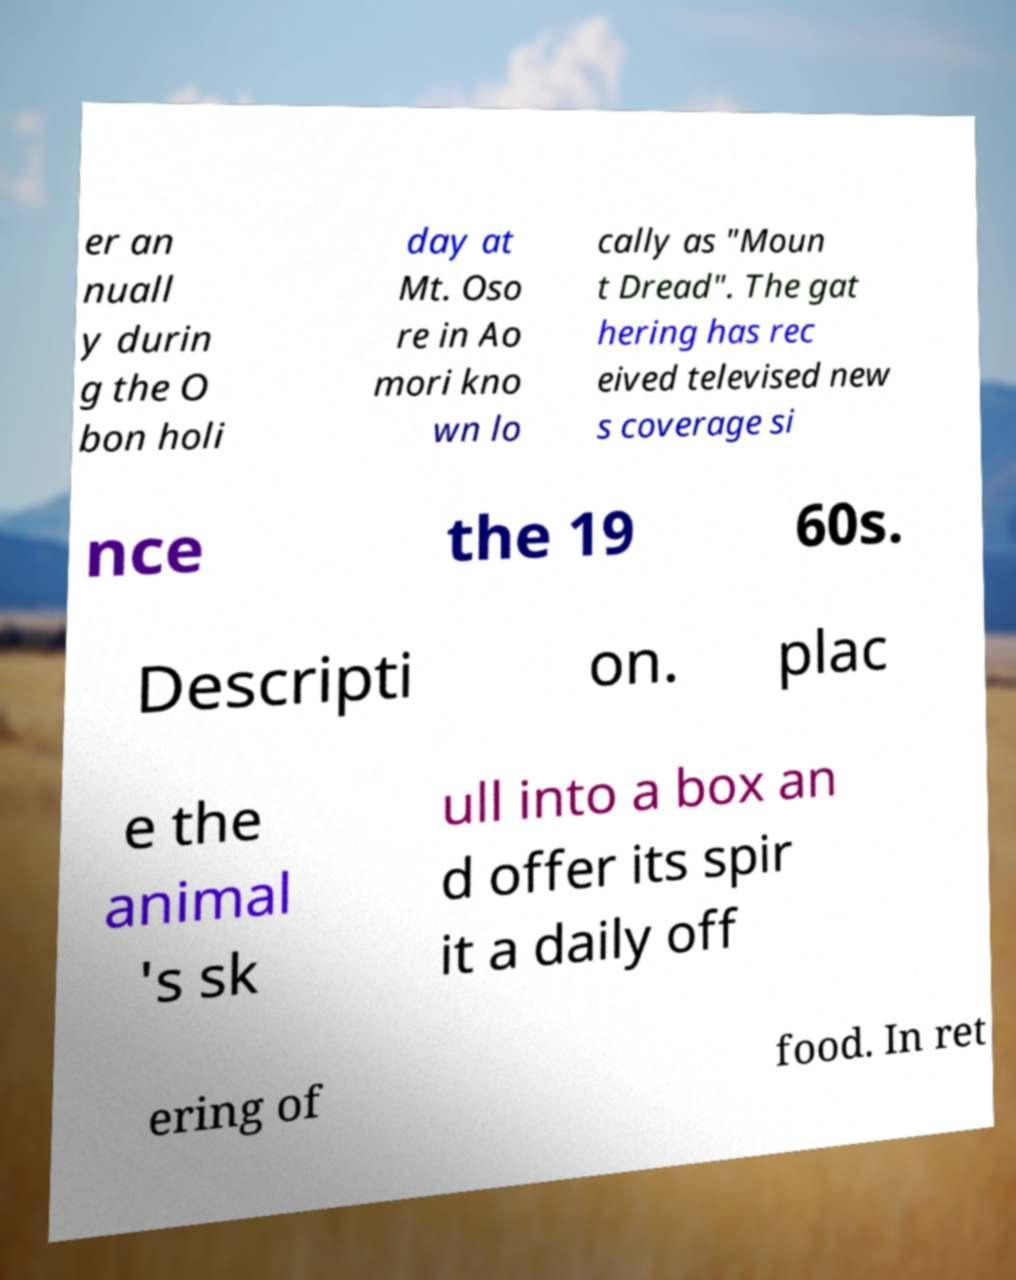Please identify and transcribe the text found in this image. er an nuall y durin g the O bon holi day at Mt. Oso re in Ao mori kno wn lo cally as "Moun t Dread". The gat hering has rec eived televised new s coverage si nce the 19 60s. Descripti on. plac e the animal 's sk ull into a box an d offer its spir it a daily off ering of food. In ret 